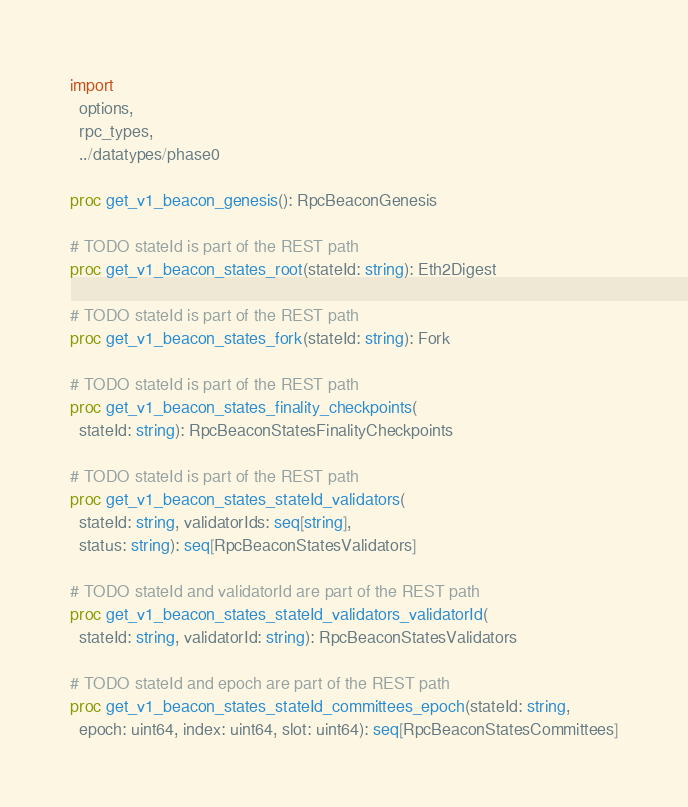<code> <loc_0><loc_0><loc_500><loc_500><_Nim_>import
  options,
  rpc_types,
  ../datatypes/phase0

proc get_v1_beacon_genesis(): RpcBeaconGenesis

# TODO stateId is part of the REST path
proc get_v1_beacon_states_root(stateId: string): Eth2Digest

# TODO stateId is part of the REST path
proc get_v1_beacon_states_fork(stateId: string): Fork

# TODO stateId is part of the REST path
proc get_v1_beacon_states_finality_checkpoints(
  stateId: string): RpcBeaconStatesFinalityCheckpoints

# TODO stateId is part of the REST path
proc get_v1_beacon_states_stateId_validators(
  stateId: string, validatorIds: seq[string],
  status: string): seq[RpcBeaconStatesValidators]

# TODO stateId and validatorId are part of the REST path
proc get_v1_beacon_states_stateId_validators_validatorId(
  stateId: string, validatorId: string): RpcBeaconStatesValidators

# TODO stateId and epoch are part of the REST path
proc get_v1_beacon_states_stateId_committees_epoch(stateId: string,
  epoch: uint64, index: uint64, slot: uint64): seq[RpcBeaconStatesCommittees]
</code> 